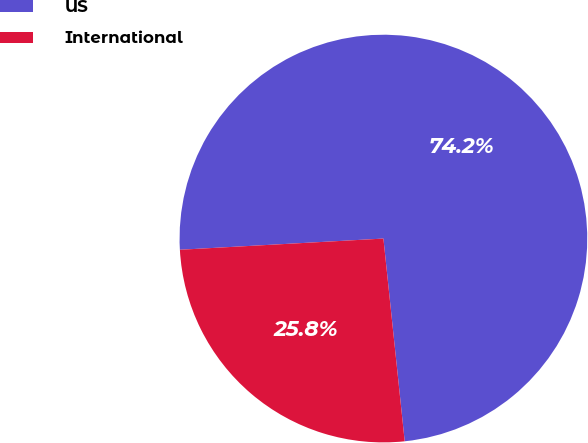Convert chart to OTSL. <chart><loc_0><loc_0><loc_500><loc_500><pie_chart><fcel>US<fcel>International<nl><fcel>74.21%<fcel>25.79%<nl></chart> 